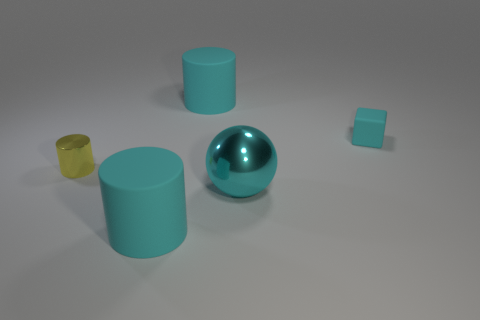Subtract all matte cylinders. How many cylinders are left? 1 Add 5 small blue matte things. How many objects exist? 10 Subtract all yellow cylinders. How many cylinders are left? 2 Subtract all cylinders. How many objects are left? 2 Subtract 0 brown cubes. How many objects are left? 5 Subtract all gray cubes. Subtract all red spheres. How many cubes are left? 1 Subtract all red cubes. How many yellow cylinders are left? 1 Subtract all cyan shiny balls. Subtract all small things. How many objects are left? 2 Add 1 big matte cylinders. How many big matte cylinders are left? 3 Add 4 small yellow shiny things. How many small yellow shiny things exist? 5 